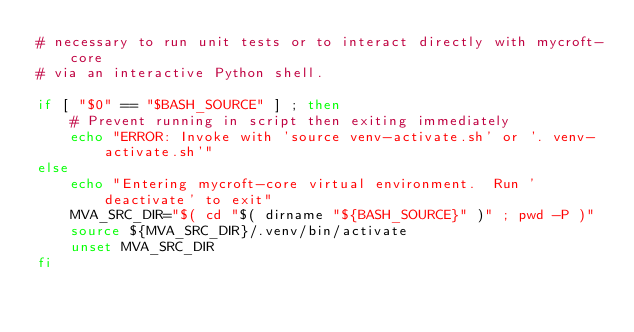<code> <loc_0><loc_0><loc_500><loc_500><_Bash_># necessary to run unit tests or to interact directly with mycroft-core
# via an interactive Python shell.

if [ "$0" == "$BASH_SOURCE" ] ; then
    # Prevent running in script then exiting immediately
    echo "ERROR: Invoke with 'source venv-activate.sh' or '. venv-activate.sh'"
else
    echo "Entering mycroft-core virtual environment.  Run 'deactivate' to exit"
    MVA_SRC_DIR="$( cd "$( dirname "${BASH_SOURCE}" )" ; pwd -P )"
    source ${MVA_SRC_DIR}/.venv/bin/activate
    unset MVA_SRC_DIR
fi
</code> 